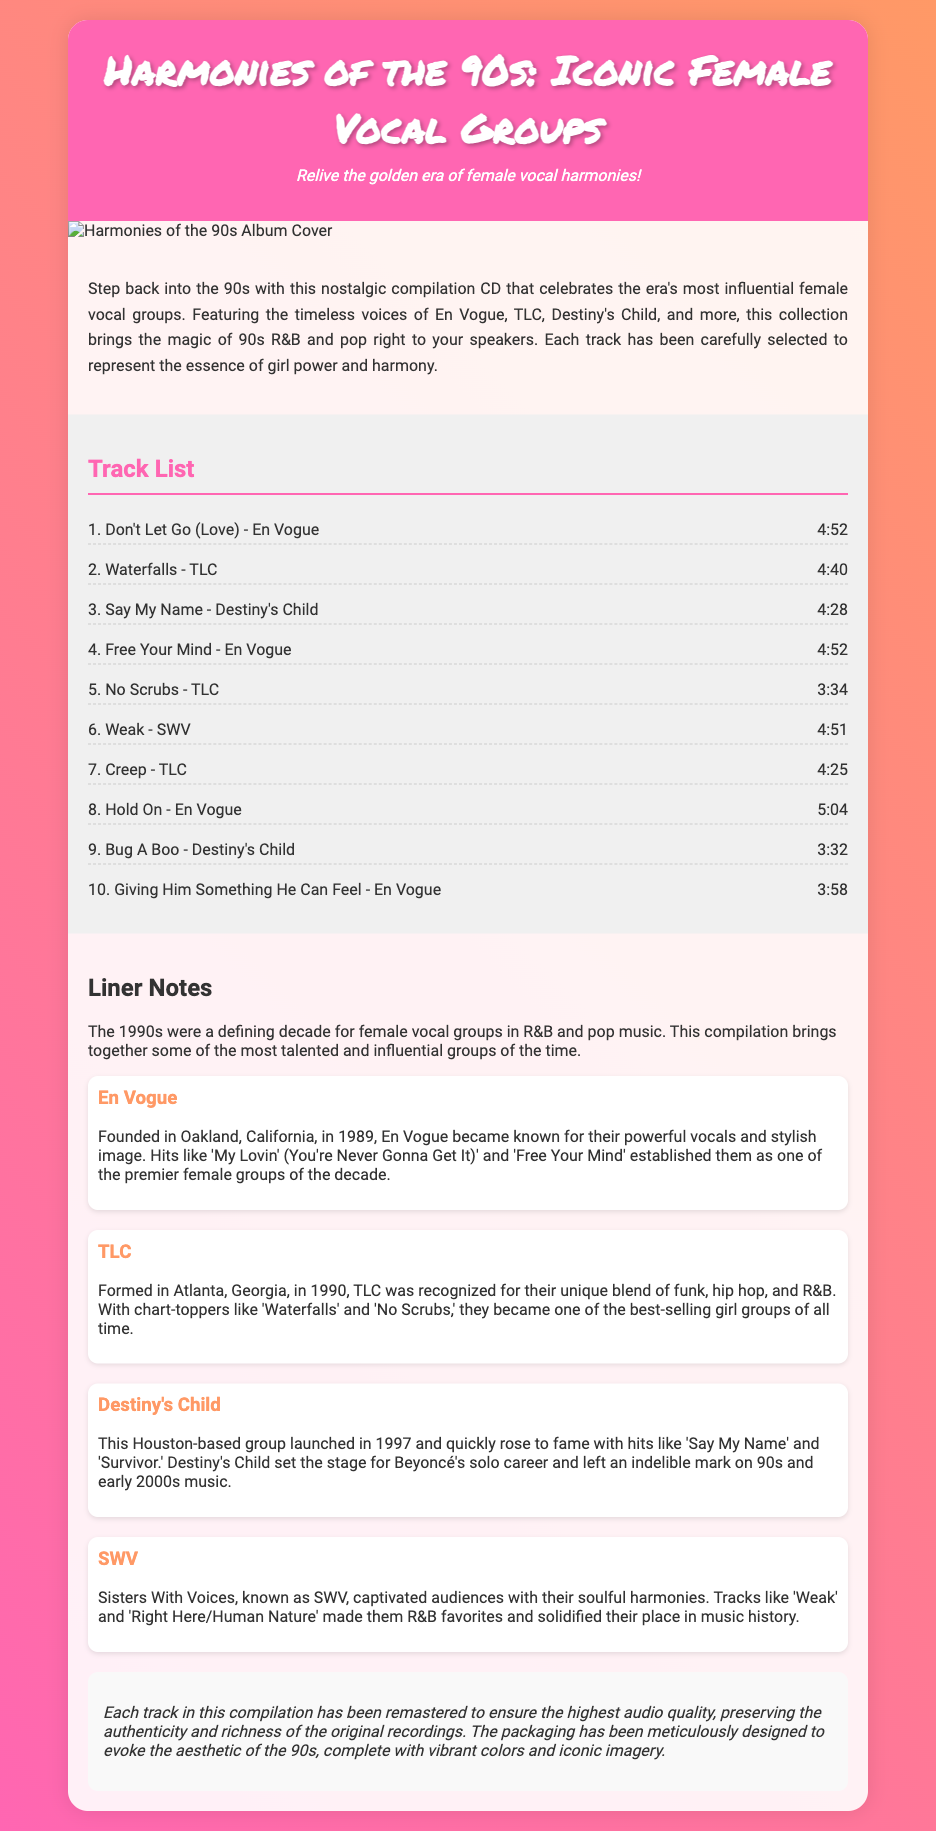what is the title of the CD? The title of the CD is found in the header section of the document.
Answer: Harmonies of the 90s: Iconic Female Vocal Groups who is one of the featured groups in the compilation? The document lists several groups that are featured in the compilation.
Answer: En Vogue how many tracks are listed in the track list? The number of tracks can be counted in the track list section of the document.
Answer: 10 which song is by SWV? The track list contains a song attributed to SWV.
Answer: Weak what year did Destiny's Child form? The document specifies the formation year of Destiny's Child in the liner notes.
Answer: 1997 which track is the longest in duration? The durations of the tracks can be compared to determine the longest track in the list.
Answer: 5:04 what is the color scheme of the background? The background color scheme is mentioned in the style section of the document.
Answer: Gradient of pink and orange how are the tracks presented in the document? The format of presenting the tracks can be observed in the tracklist section.
Answer: As a list with song titles and durations what kind of notes are included in the compilation? The document describes the types of notes provided within the liner notes.
Answer: Liner notes what is emphasized about the audio quality of the tracks? The production notes discuss the quality of the audio for the tracks.
Answer: Remastered for highest audio quality 